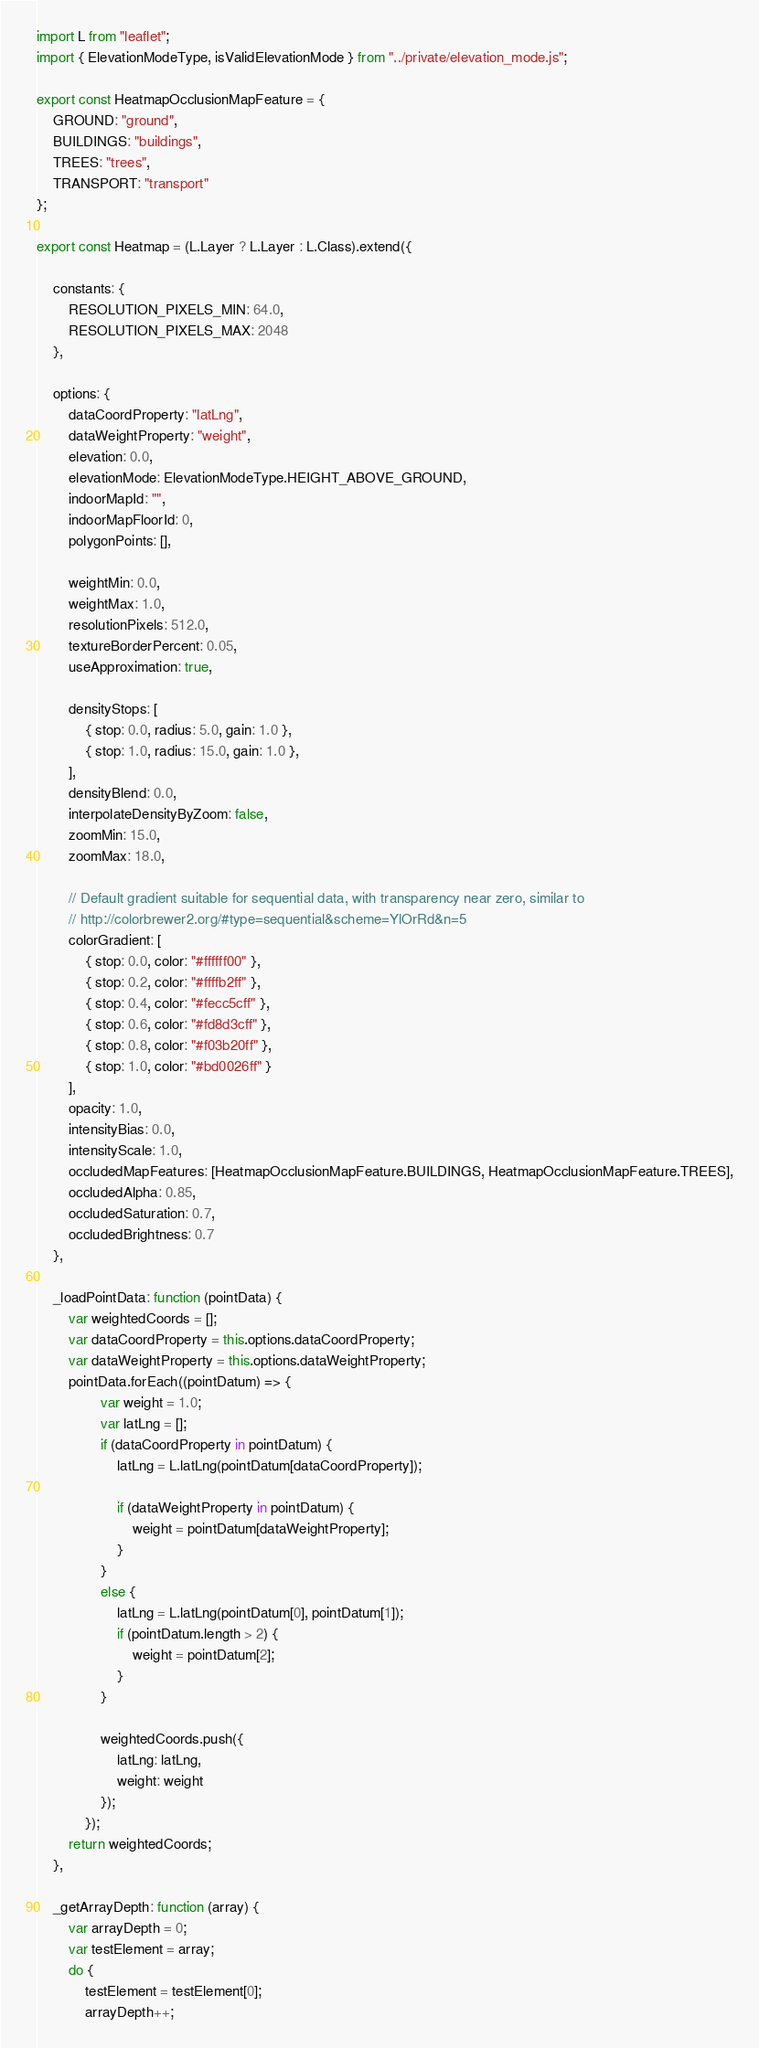<code> <loc_0><loc_0><loc_500><loc_500><_JavaScript_>import L from "leaflet";
import { ElevationModeType, isValidElevationMode } from "../private/elevation_mode.js";

export const HeatmapOcclusionMapFeature = {
    GROUND: "ground",
    BUILDINGS: "buildings",
    TREES: "trees",
    TRANSPORT: "transport"
};

export const Heatmap = (L.Layer ? L.Layer : L.Class).extend({

    constants: {
        RESOLUTION_PIXELS_MIN: 64.0,
        RESOLUTION_PIXELS_MAX: 2048
    },

    options: {
        dataCoordProperty: "latLng",
        dataWeightProperty: "weight",
        elevation: 0.0,
        elevationMode: ElevationModeType.HEIGHT_ABOVE_GROUND,
        indoorMapId: "",
        indoorMapFloorId: 0,
        polygonPoints: [],

        weightMin: 0.0,
        weightMax: 1.0,
        resolutionPixels: 512.0,
        textureBorderPercent: 0.05,
        useApproximation: true,

        densityStops: [
            { stop: 0.0, radius: 5.0, gain: 1.0 },
            { stop: 1.0, radius: 15.0, gain: 1.0 },
        ],
        densityBlend: 0.0,
        interpolateDensityByZoom: false,
        zoomMin: 15.0,
        zoomMax: 18.0,

        // Default gradient suitable for sequential data, with transparency near zero, similar to
        // http://colorbrewer2.org/#type=sequential&scheme=YlOrRd&n=5
        colorGradient: [
            { stop: 0.0, color: "#ffffff00" },
            { stop: 0.2, color: "#ffffb2ff" },
            { stop: 0.4, color: "#fecc5cff" },
            { stop: 0.6, color: "#fd8d3cff" },
            { stop: 0.8, color: "#f03b20ff" },
            { stop: 1.0, color: "#bd0026ff" }
        ],
        opacity: 1.0,
        intensityBias: 0.0,
        intensityScale: 1.0,
        occludedMapFeatures: [HeatmapOcclusionMapFeature.BUILDINGS, HeatmapOcclusionMapFeature.TREES],
        occludedAlpha: 0.85,
        occludedSaturation: 0.7,
        occludedBrightness: 0.7
    },

    _loadPointData: function (pointData) {
        var weightedCoords = [];
        var dataCoordProperty = this.options.dataCoordProperty;
        var dataWeightProperty = this.options.dataWeightProperty;
        pointData.forEach((pointDatum) => {
                var weight = 1.0;
                var latLng = [];
                if (dataCoordProperty in pointDatum) {
                    latLng = L.latLng(pointDatum[dataCoordProperty]);

                    if (dataWeightProperty in pointDatum) {
                        weight = pointDatum[dataWeightProperty];
                    }
                }
                else {
                    latLng = L.latLng(pointDatum[0], pointDatum[1]);
                    if (pointDatum.length > 2) {
                        weight = pointDatum[2];
                    }
                }

                weightedCoords.push({
                    latLng: latLng,
                    weight: weight
                });
            });
        return weightedCoords;
    },

    _getArrayDepth: function (array) {
        var arrayDepth = 0;
        var testElement = array;
        do {
            testElement = testElement[0];
            arrayDepth++;</code> 